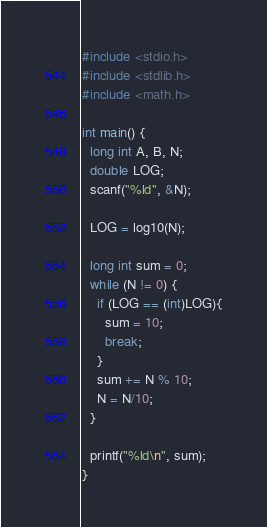Convert code to text. <code><loc_0><loc_0><loc_500><loc_500><_C_>#include <stdio.h>
#include <stdlib.h>
#include <math.h>

int main() {
  long int A, B, N;
  double LOG;
  scanf("%ld", &N);

  LOG = log10(N);

  long int sum = 0; 
  while (N != 0) { 
    if (LOG == (int)LOG){
      sum = 10;
      break;
    }
    sum += N % 10; 
    N = N/10; 
  } 

  printf("%ld\n", sum);
}
</code> 